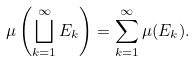Convert formula to latex. <formula><loc_0><loc_0><loc_500><loc_500>\mu \left ( \bigsqcup _ { k = 1 } ^ { \infty } E _ { k } \right ) = \sum _ { k = 1 } ^ { \infty } \mu ( E _ { k } ) .</formula> 